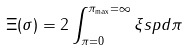<formula> <loc_0><loc_0><loc_500><loc_500>\Xi ( \sigma ) = 2 \int ^ { \pi _ { \max } = \infty } _ { \pi = 0 } \xi s p d \pi</formula> 